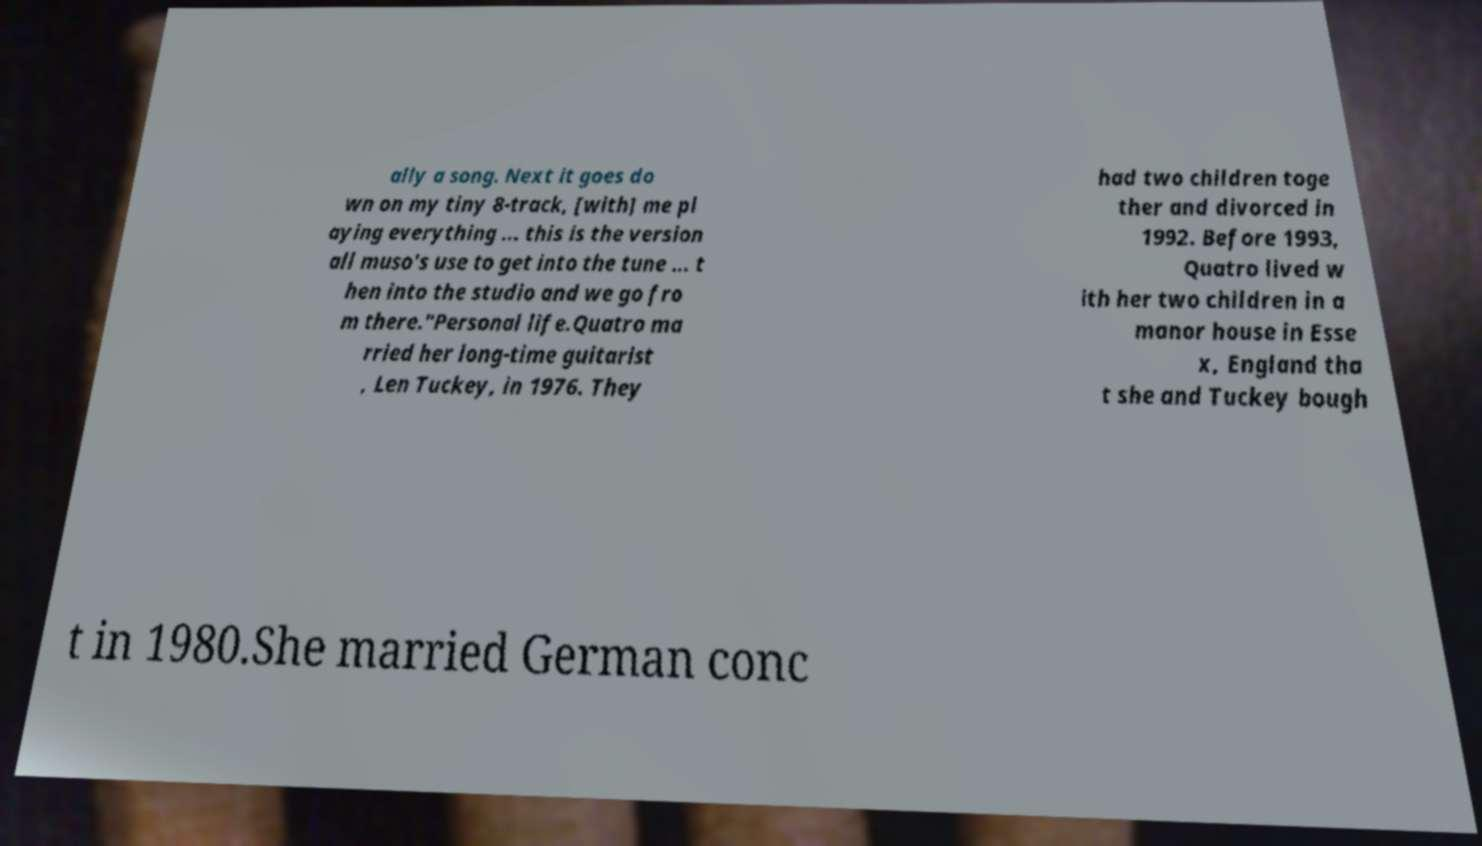I need the written content from this picture converted into text. Can you do that? ally a song. Next it goes do wn on my tiny 8-track, [with] me pl aying everything ... this is the version all muso's use to get into the tune ... t hen into the studio and we go fro m there."Personal life.Quatro ma rried her long-time guitarist , Len Tuckey, in 1976. They had two children toge ther and divorced in 1992. Before 1993, Quatro lived w ith her two children in a manor house in Esse x, England tha t she and Tuckey bough t in 1980.She married German conc 